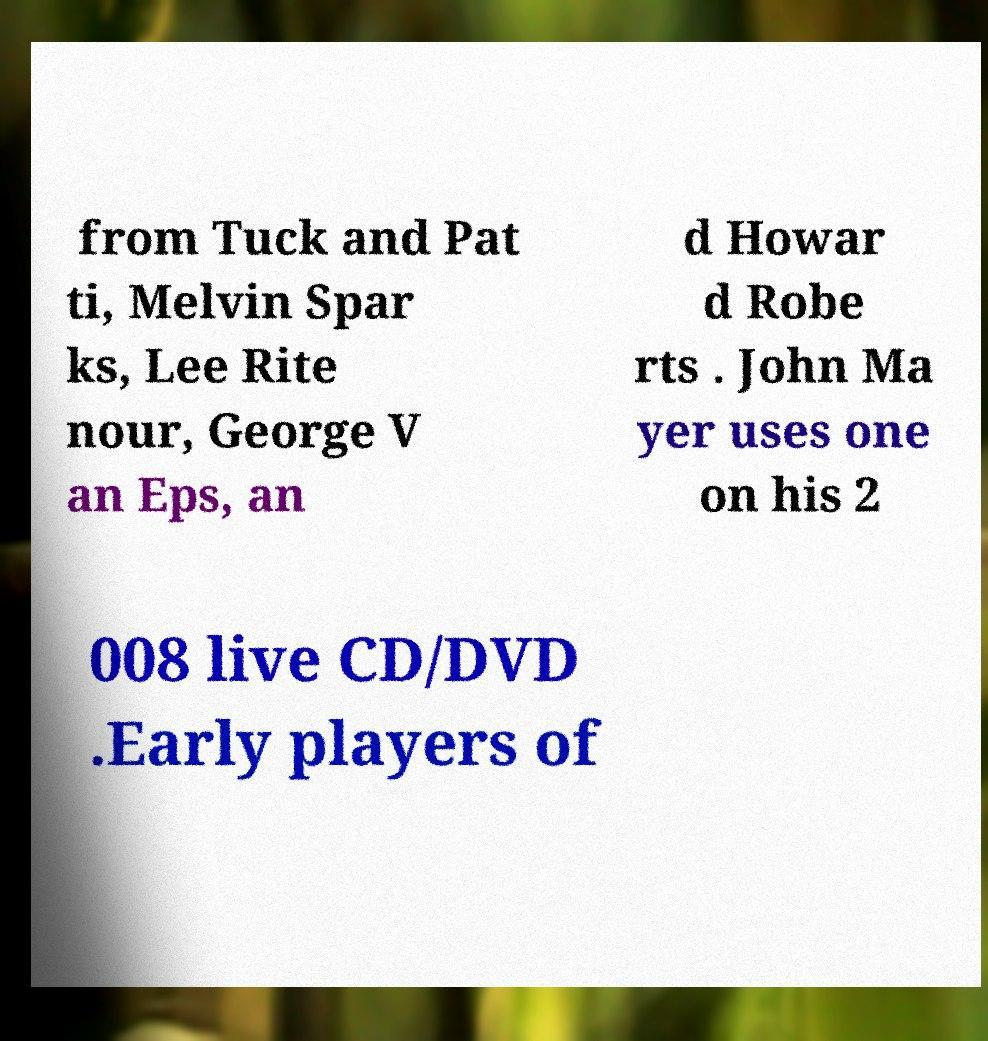What messages or text are displayed in this image? I need them in a readable, typed format. from Tuck and Pat ti, Melvin Spar ks, Lee Rite nour, George V an Eps, an d Howar d Robe rts . John Ma yer uses one on his 2 008 live CD/DVD .Early players of 